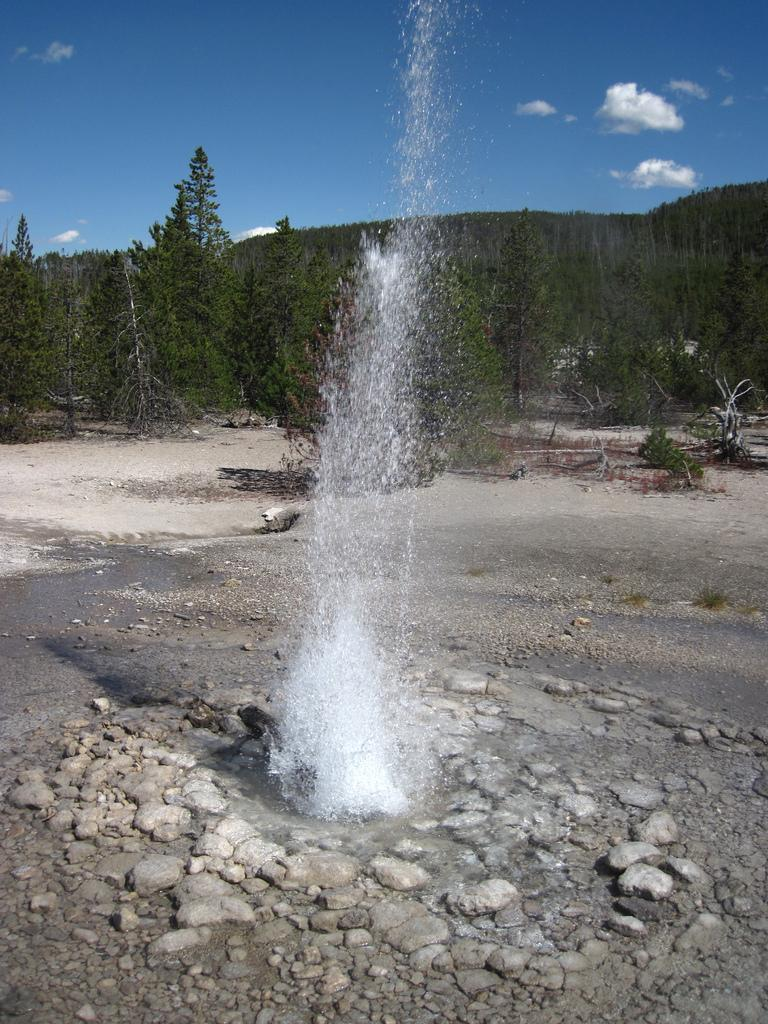What is the main element in the image? There is water in the image. What other objects or features can be seen in the image? There are rocks in the image. What can be seen in the background of the image? There are trees in the background of the image. How would you describe the sky in the image? The sky is blue in color and has clouds visible. What type of notebook is being offered in the image? There is no notebook present in the image. How does the dust affect the water in the image? There is no dust present in the image, so it cannot affect the water. 